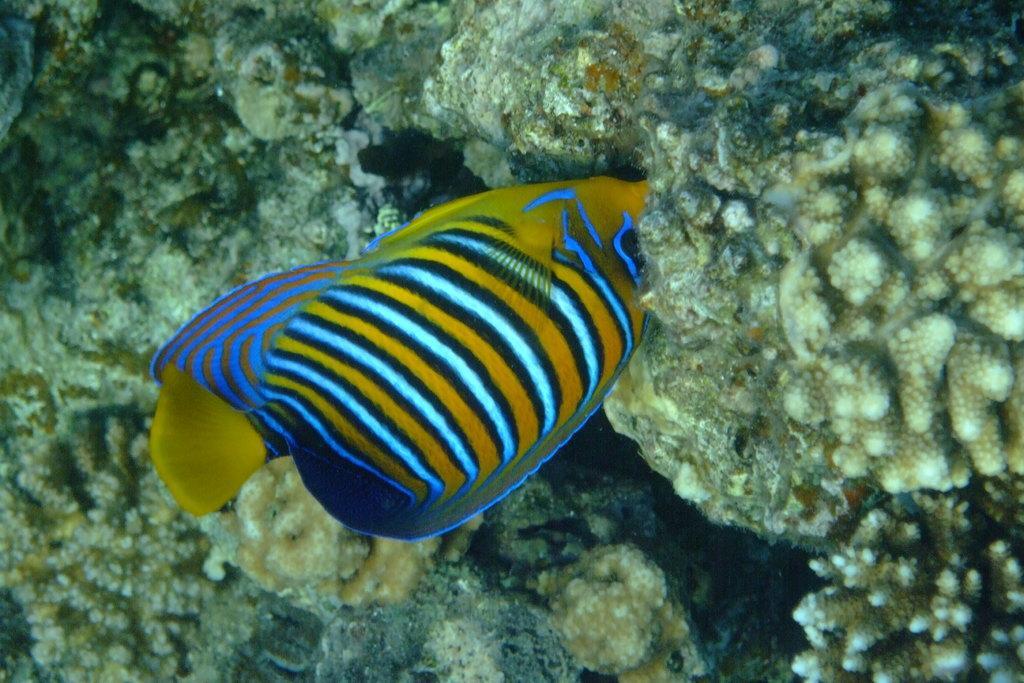Can you describe this image briefly? The picture is taken in water. In the center of the picture there is a fish. In the picture there are coral reefs. 